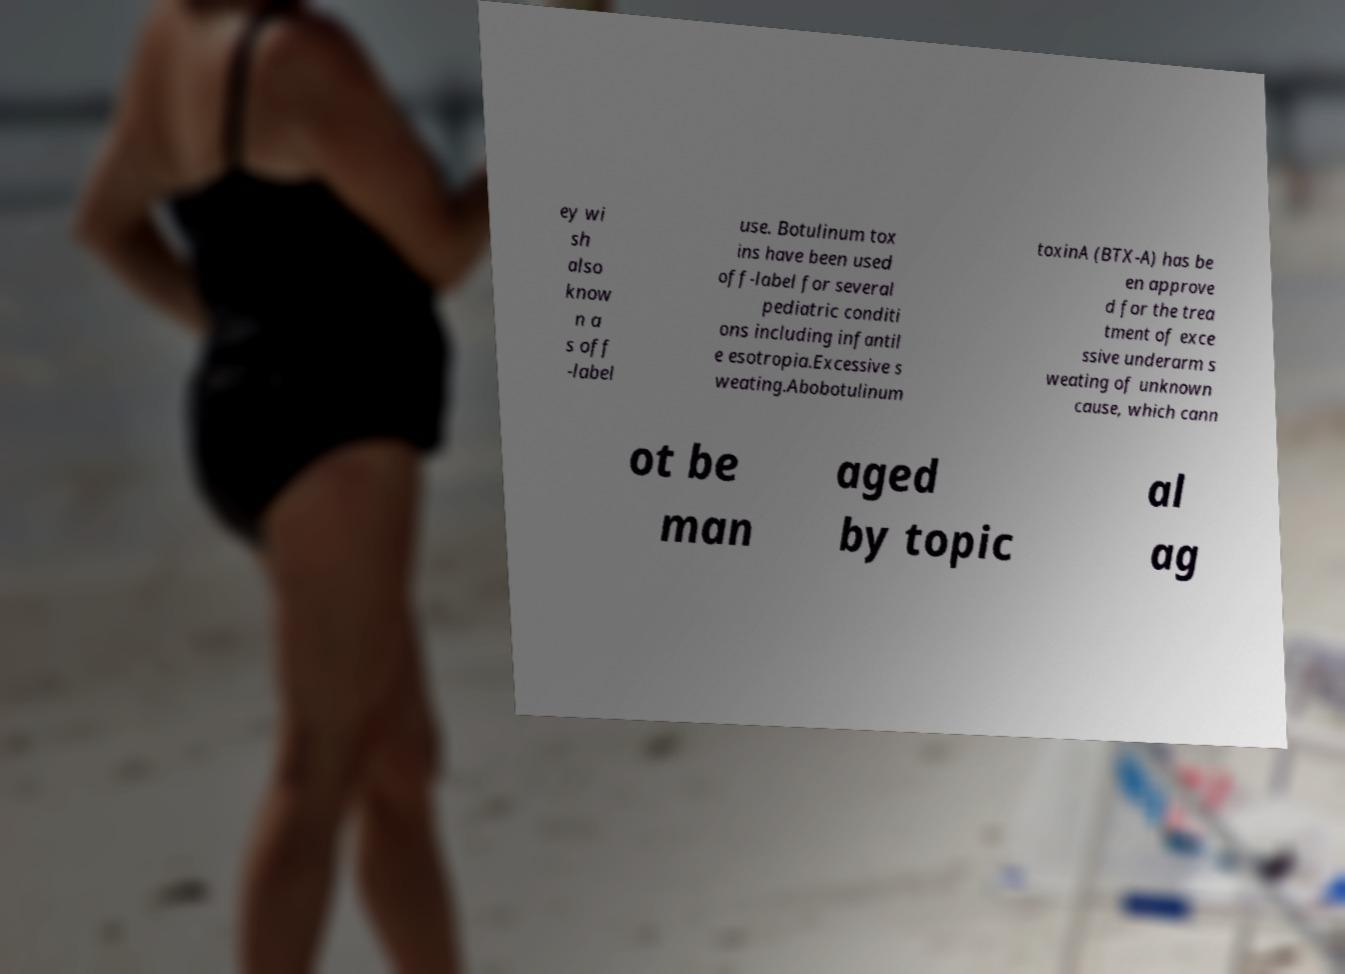There's text embedded in this image that I need extracted. Can you transcribe it verbatim? ey wi sh also know n a s off -label use. Botulinum tox ins have been used off-label for several pediatric conditi ons including infantil e esotropia.Excessive s weating.Abobotulinum toxinA (BTX-A) has be en approve d for the trea tment of exce ssive underarm s weating of unknown cause, which cann ot be man aged by topic al ag 